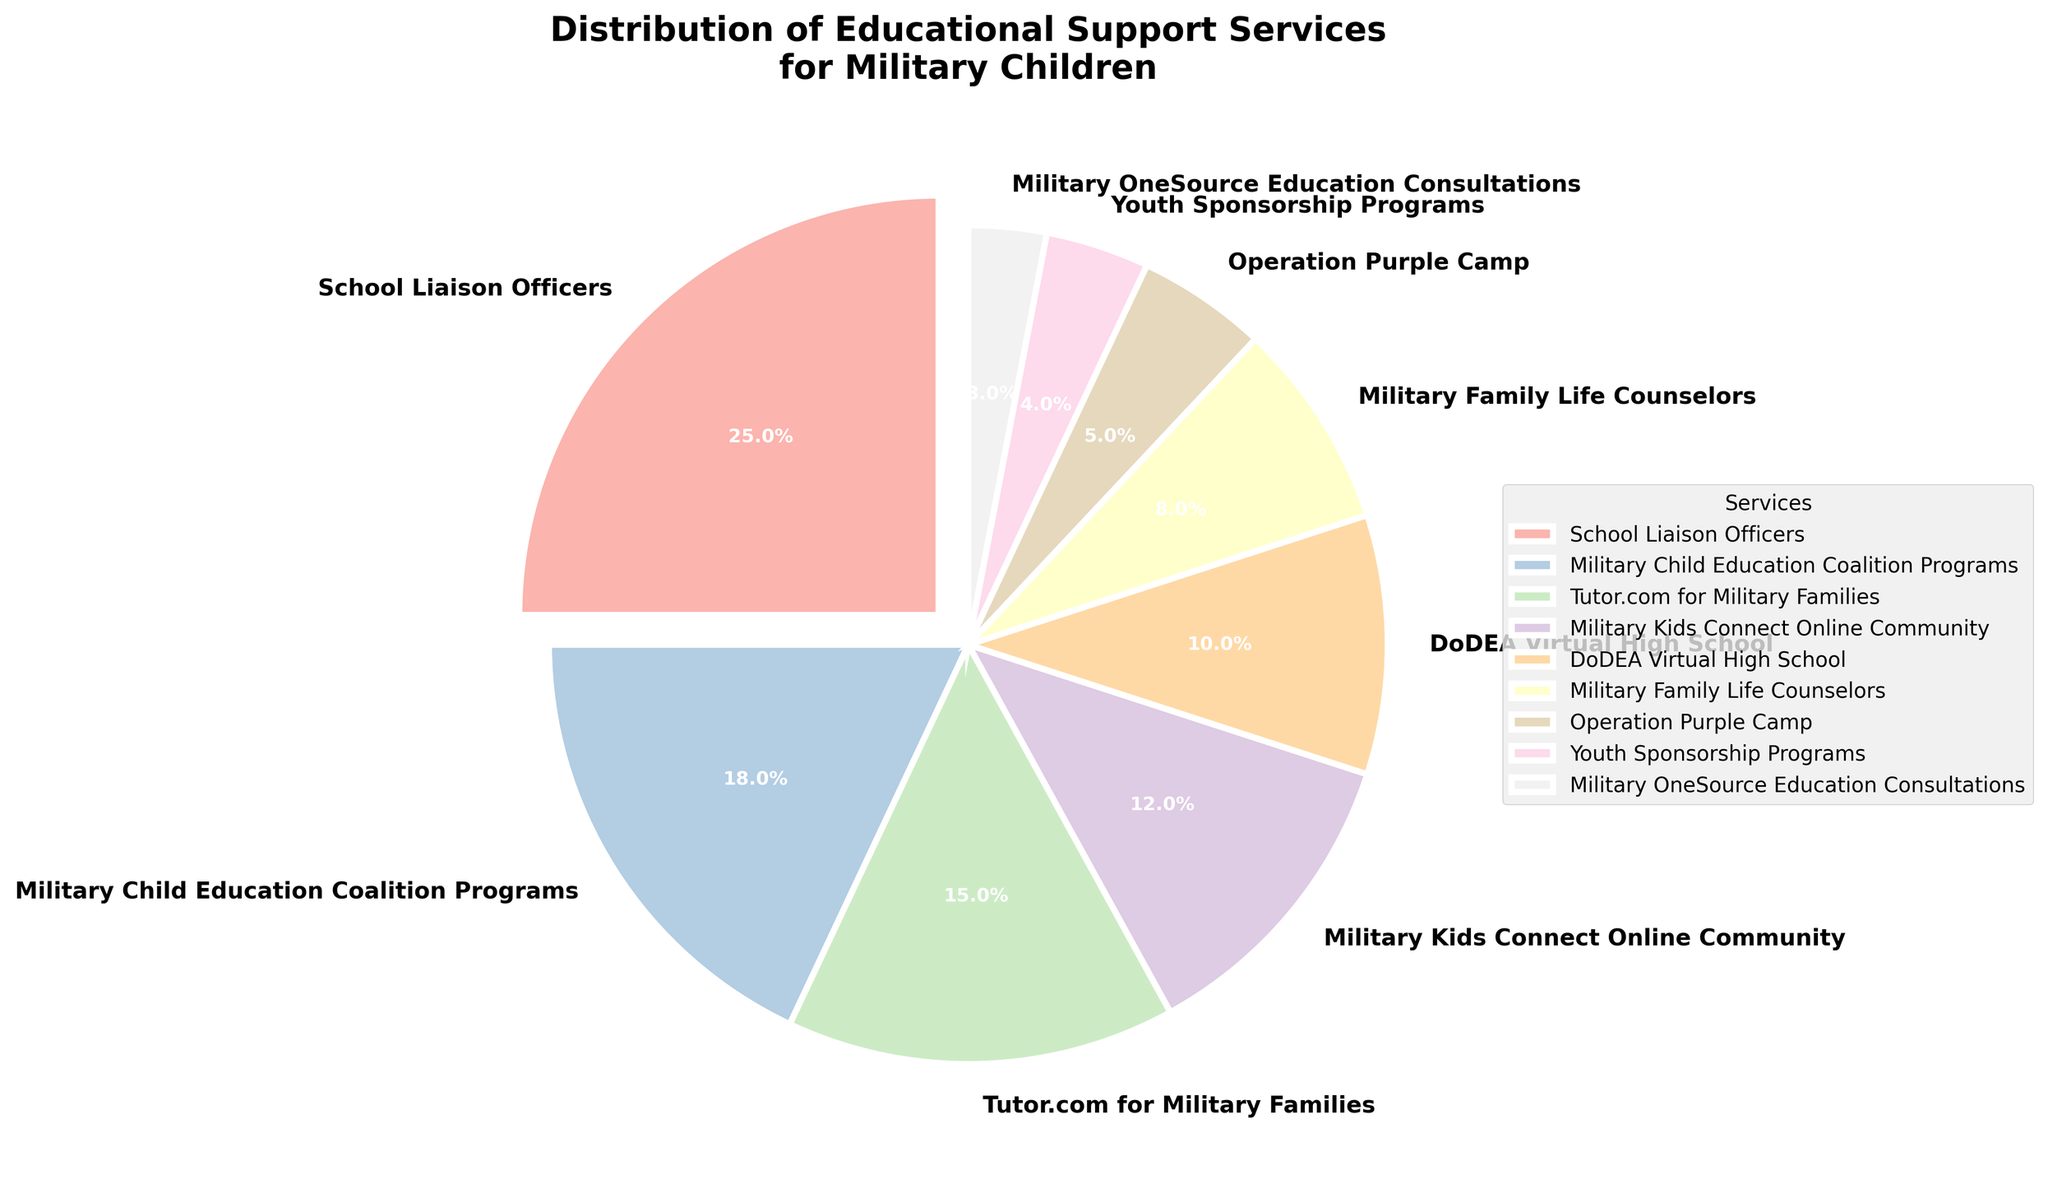What is the largest educational support service available for military children? The figure shows a pie chart with different segments representing the distribution of educational support services. The segment labeled 'School Liaison Officers' has the largest portion, corresponding to 25%.
Answer: School Liaison Officers Which service has the smallest share in the distribution of educational support services? The smallest segment in the pie chart, corresponding to 3%, is labeled 'Military OneSource Education Consultations'.
Answer: Military OneSource Education Consultations What is the combined percentage of 'Tutor.com for Military Families' and 'Military Child Education Coalition Programs'? 'Tutor.com for Military Families' has a percentage of 15% and 'Military Child Education Coalition Programs' has 18%. By adding these two percentages, we get 15% + 18% = 33%.
Answer: 33% Are 'DoDEA Virtual High School' and 'Military Family Life Counselors' collectively more than 'School Liaison Officers'? 'DoDEA Virtual High School' has 10% and 'Military Family Life Counselors' has 8%. Together, they add up to 18%. 'School Liaison Officers' has 25%. Since 18% is less than 25%, their combined percentage is not more.
Answer: No How does the percentage of 'Operation Purple Camp' compare to 'Youth Sponsorship Programs'? 'Operation Purple Camp' has a percentage of 5% and 'Youth Sponsorship Programs' has 4%. Since 5% is greater than 4%, 'Operation Purple Camp' has a higher percentage.
Answer: Operation Purple Camp has a higher percentage Which services have percentages between 10% and 20%? The segments within the range of 10% to 20% are 'Military Child Education Coalition Programs' with 18%, 'Tutor.com for Military Families' with 15%, and 'Military Kids Connect Online Community' with 12%.
Answer: Military Child Education Coalition Programs, Tutor.com for Military Families, Military Kids Connect Online Community What is the difference in percentage between 'School Liaison Officers' and 'Military OneSource Education Consultations'? 'School Liaison Officers' has 25% and 'Military OneSource Education Consultations' has 3%. Subtracting the two percentages, 25% - 3% = 22%.
Answer: 22% What percentage of educational support services is provided by 'DoDEA Virtual High School' and 'Youth Sponsorship Programs' together? 'DoDEA Virtual High School' has 10% and 'Youth Sponsorship Programs' has 4%. Adding these together, 10% + 4% = 14%.
Answer: 14% If the percentages of 'Military Family Life Counselors' and 'Operation Purple Camp' are summed, which service has an equal or nearly equal percentage? 'Military Family Life Counselors' is 8% and 'Operation Purple Camp' is 5%. Their sum is 8% + 5% = 13%. The service 'Military Kids Connect Online Community' has a percentage of 12%, which is the closest to 13%.
Answer: Military Kids Connect Online Community 